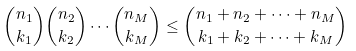Convert formula to latex. <formula><loc_0><loc_0><loc_500><loc_500>\binom { n _ { 1 } } { k _ { 1 } } \binom { n _ { 2 } } { k _ { 2 } } \cdots \binom { n _ { M } } { k _ { M } } \leq \binom { n _ { 1 } + n _ { 2 } + \cdots + n _ { M } } { k _ { 1 } + k _ { 2 } + \cdots + k _ { M } }</formula> 